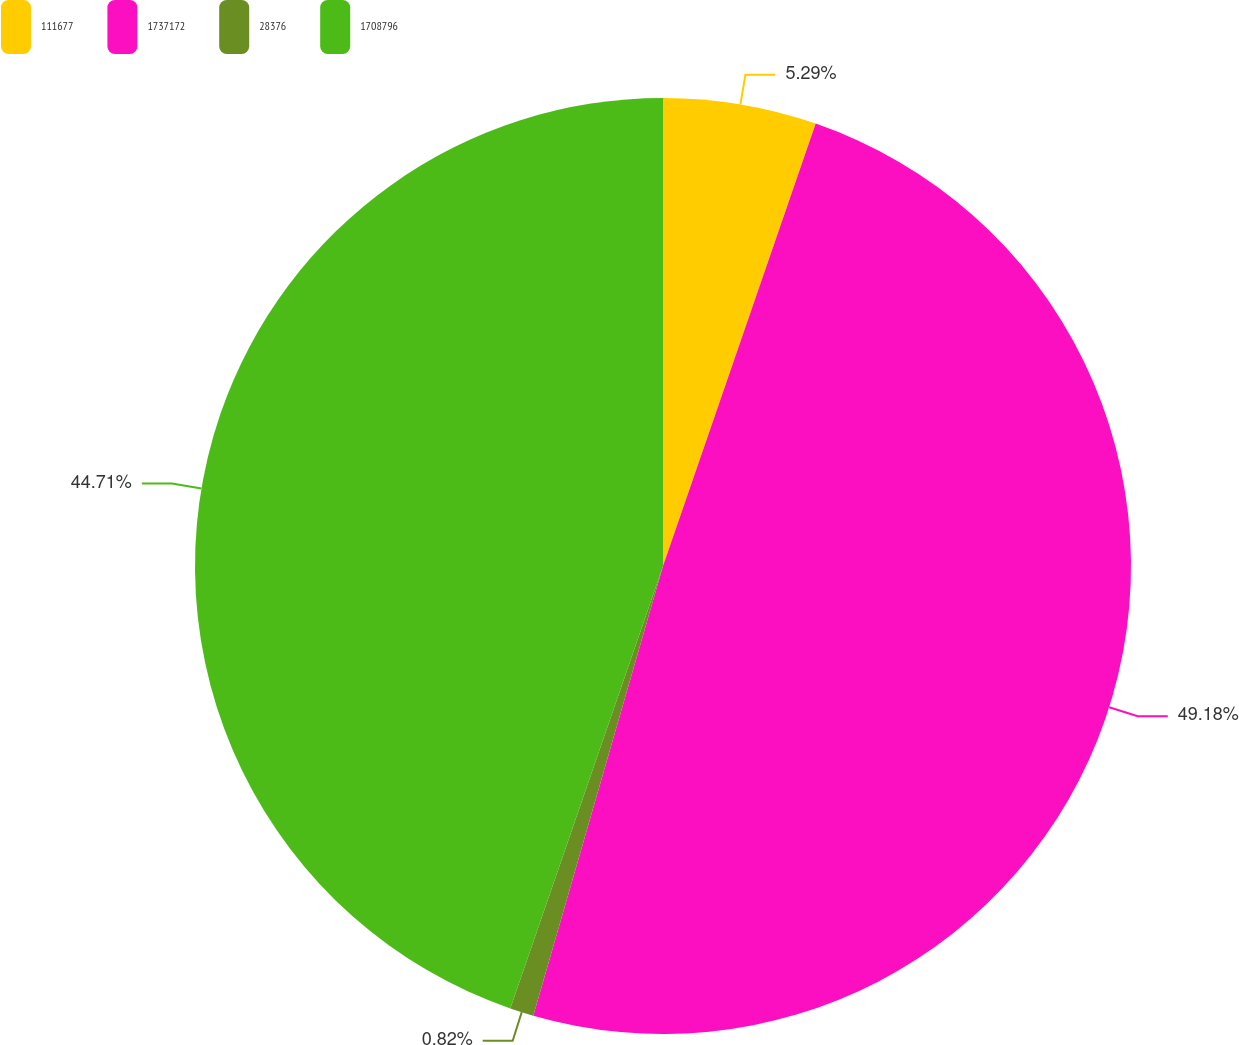<chart> <loc_0><loc_0><loc_500><loc_500><pie_chart><fcel>111677<fcel>1737172<fcel>28376<fcel>1708796<nl><fcel>5.29%<fcel>49.18%<fcel>0.82%<fcel>44.71%<nl></chart> 